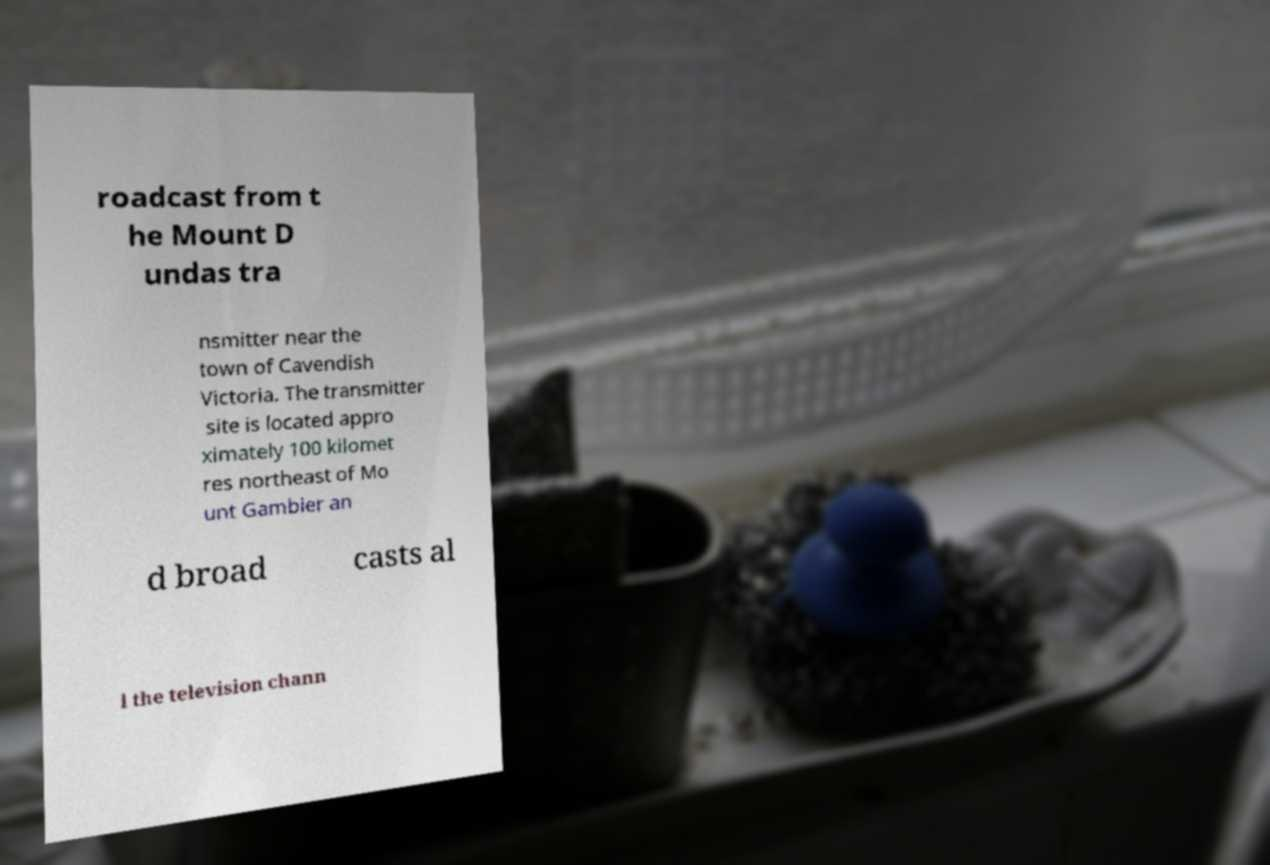I need the written content from this picture converted into text. Can you do that? roadcast from t he Mount D undas tra nsmitter near the town of Cavendish Victoria. The transmitter site is located appro ximately 100 kilomet res northeast of Mo unt Gambier an d broad casts al l the television chann 